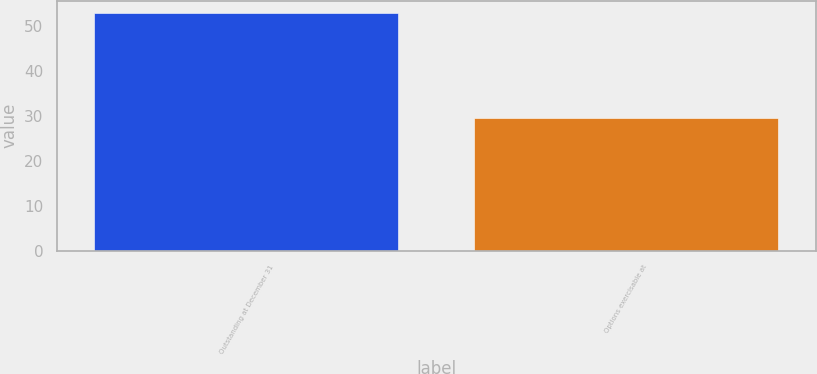<chart> <loc_0><loc_0><loc_500><loc_500><bar_chart><fcel>Outstanding at December 31<fcel>Options exercisable at<nl><fcel>52.9<fcel>29.4<nl></chart> 